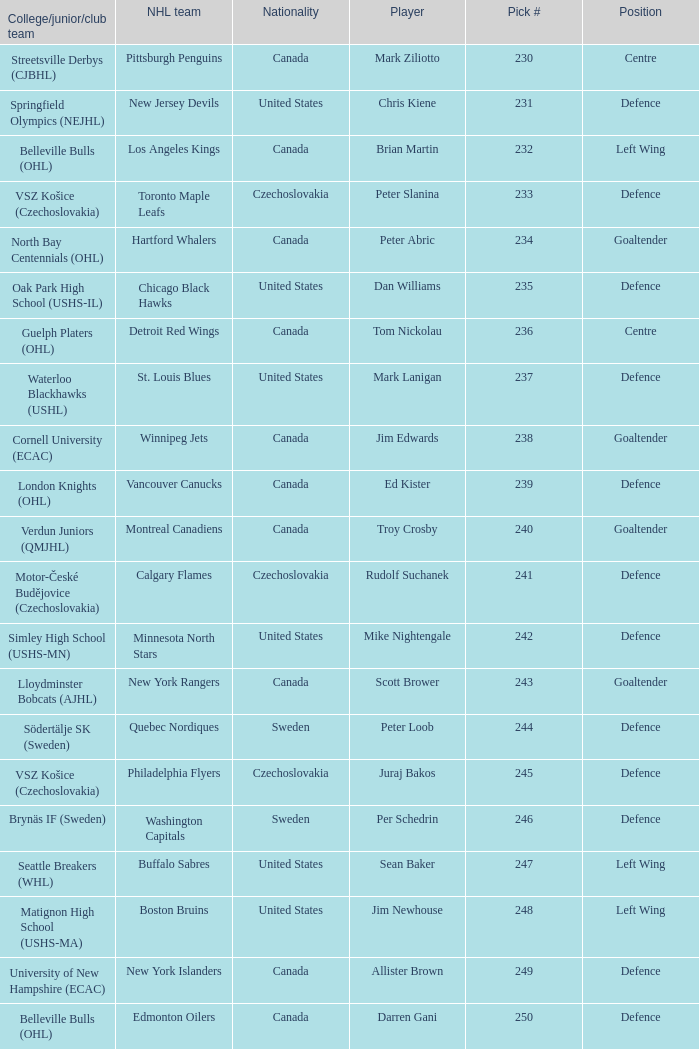To which organziation does the  winnipeg jets belong to? Cornell University (ECAC). 